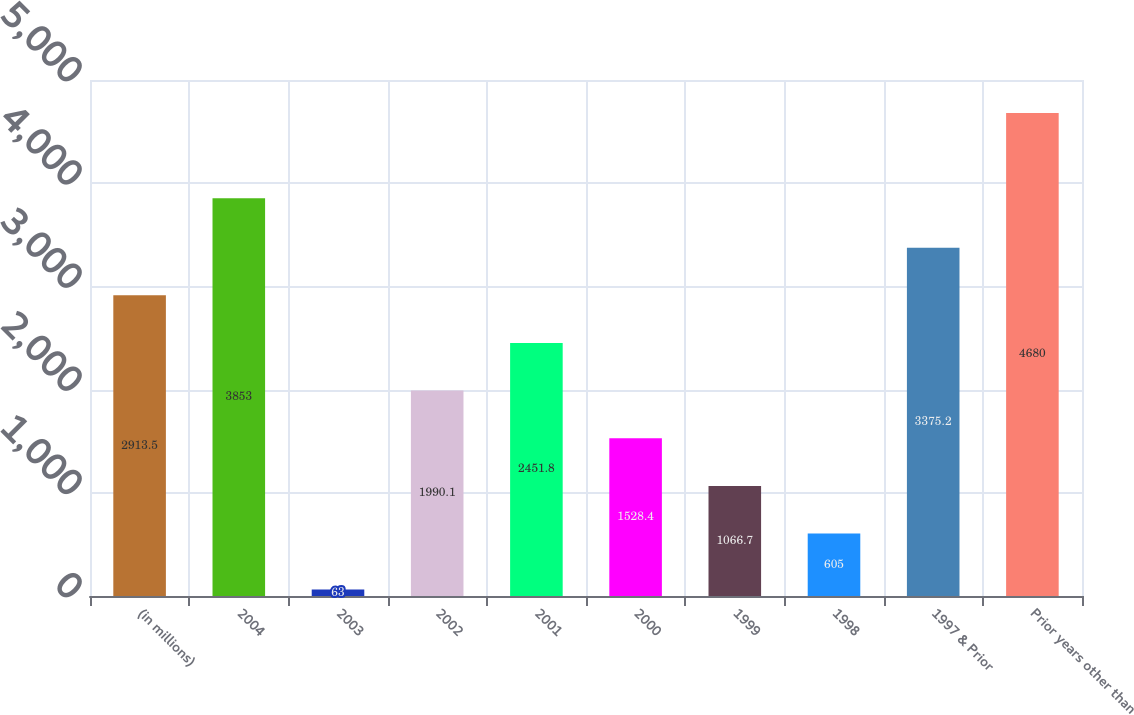Convert chart. <chart><loc_0><loc_0><loc_500><loc_500><bar_chart><fcel>(in millions)<fcel>2004<fcel>2003<fcel>2002<fcel>2001<fcel>2000<fcel>1999<fcel>1998<fcel>1997 & Prior<fcel>Prior years other than<nl><fcel>2913.5<fcel>3853<fcel>63<fcel>1990.1<fcel>2451.8<fcel>1528.4<fcel>1066.7<fcel>605<fcel>3375.2<fcel>4680<nl></chart> 